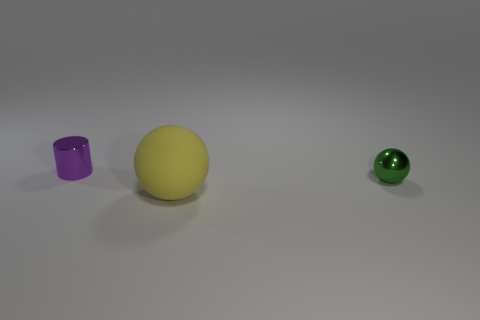Add 1 large yellow things. How many objects exist? 4 Subtract all cylinders. How many objects are left? 2 Add 2 tiny cyan matte things. How many tiny cyan matte things exist? 2 Subtract 0 blue cylinders. How many objects are left? 3 Subtract all big red rubber spheres. Subtract all big spheres. How many objects are left? 2 Add 2 green objects. How many green objects are left? 3 